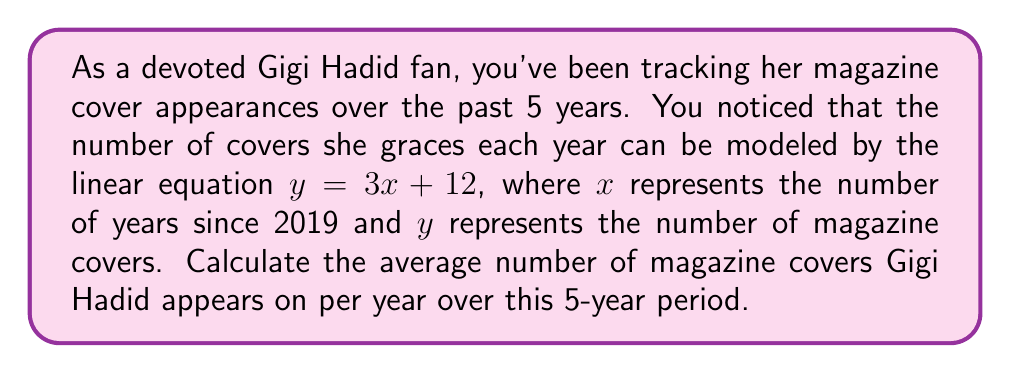Could you help me with this problem? 1) The linear equation is $y = 3x + 12$, where $x$ is the number of years since 2019 and $y$ is the number of covers.

2) We need to calculate the number of covers for each year from 2019 to 2023:

   2019 ($x = 0$): $y = 3(0) + 12 = 12$ covers
   2020 ($x = 1$): $y = 3(1) + 12 = 15$ covers
   2021 ($x = 2$): $y = 3(2) + 12 = 18$ covers
   2022 ($x = 3$): $y = 3(3) + 12 = 21$ covers
   2023 ($x = 4$): $y = 3(4) + 12 = 24$ covers

3) To find the average, we sum all covers and divide by the number of years:

   $$\text{Average} = \frac{12 + 15 + 18 + 21 + 24}{5} = \frac{90}{5} = 18$$

Therefore, Gigi Hadid appears on an average of 18 magazine covers per year over this 5-year period.
Answer: 18 covers per year 